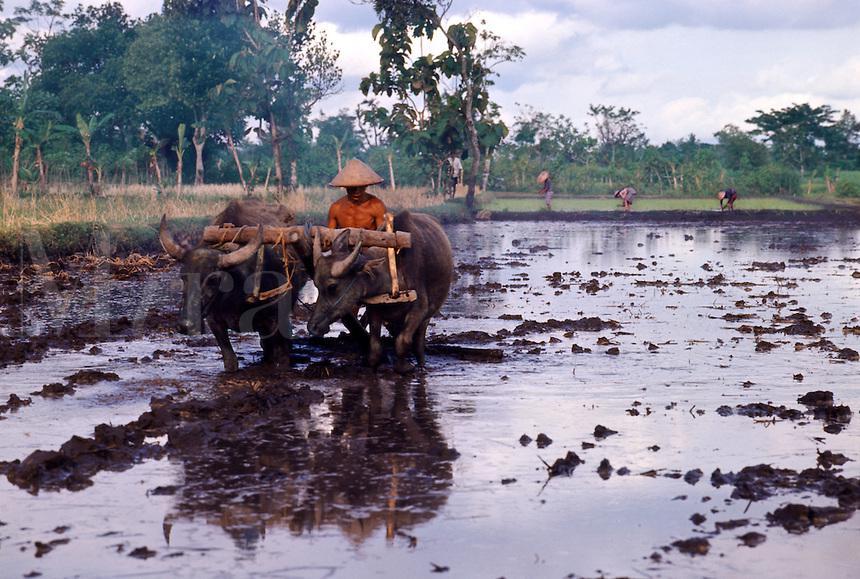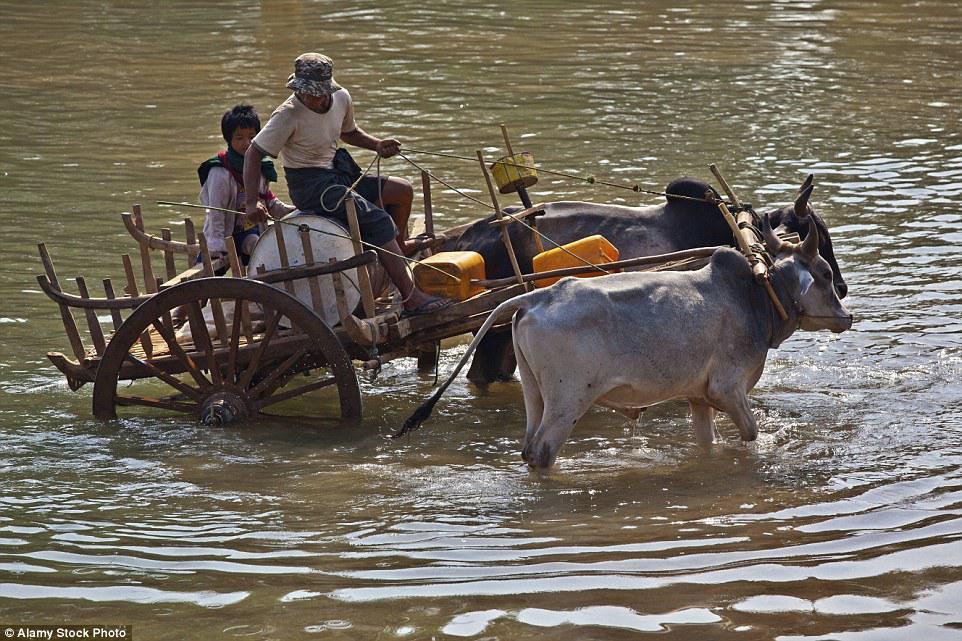The first image is the image on the left, the second image is the image on the right. Given the left and right images, does the statement "Every single bovine appears to be part of a race." hold true? Answer yes or no. No. The first image is the image on the left, the second image is the image on the right. Analyze the images presented: Is the assertion "Each image features a race where a team of two water buffalo is driven forward by a man wielding a stick." valid? Answer yes or no. No. 